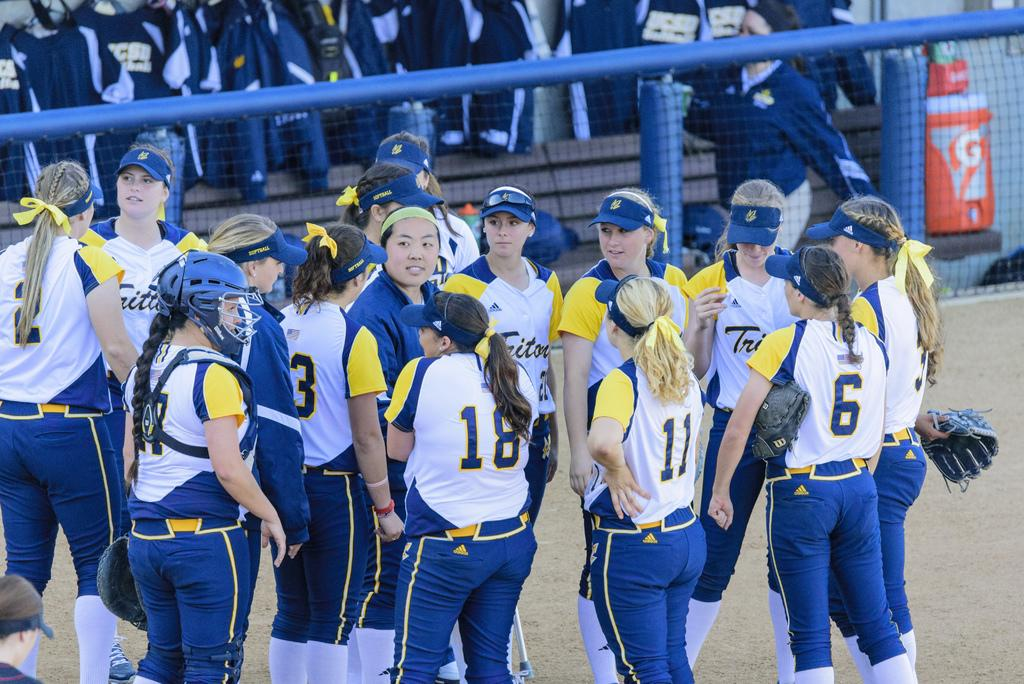<image>
Give a short and clear explanation of the subsequent image. One of the several female players has the number 11 on her shirt 